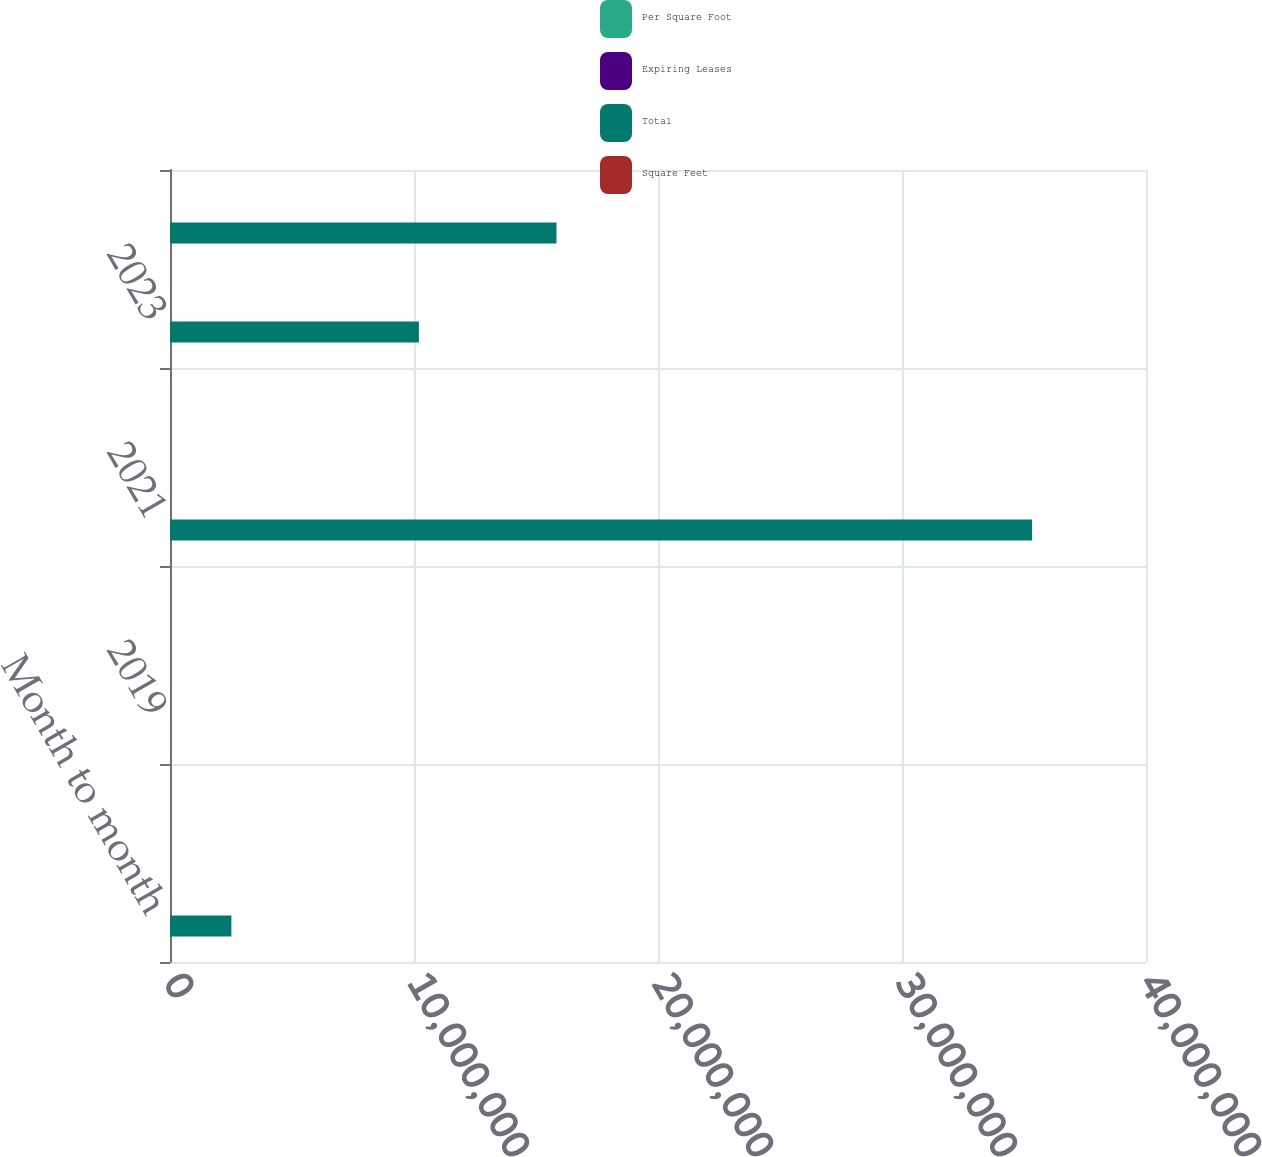Convert chart. <chart><loc_0><loc_0><loc_500><loc_500><stacked_bar_chart><ecel><fcel>Month to month<fcel>2018<fcel>2019<fcel>2020<fcel>2021<fcel>2022<fcel>2023<fcel>2024<nl><fcel>Per Square Foot<fcel>32<fcel>105<fcel>94<fcel>85<fcel>60<fcel>59<fcel>20<fcel>35<nl><fcel>Expiring Leases<fcel>1.1<fcel>11.3<fcel>13.7<fcel>10.1<fcel>9.5<fcel>13.8<fcel>2.7<fcel>4.5<nl><fcel>Total<fcel>2.516e+06<fcel>44.8<fcel>44.8<fcel>44.8<fcel>3.5331e+07<fcel>44.8<fcel>1.0202e+07<fcel>1.584e+07<nl><fcel>Square Feet<fcel>27.05<fcel>46.3<fcel>45.05<fcel>50.86<fcel>44.55<fcel>45.44<fcel>45.34<fcel>42.02<nl></chart> 